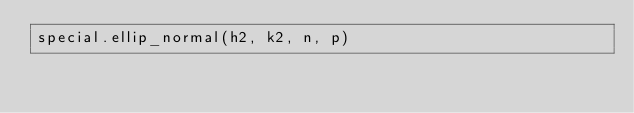<code> <loc_0><loc_0><loc_500><loc_500><_Python_>special.ellip_normal(h2, k2, n, p)</code> 